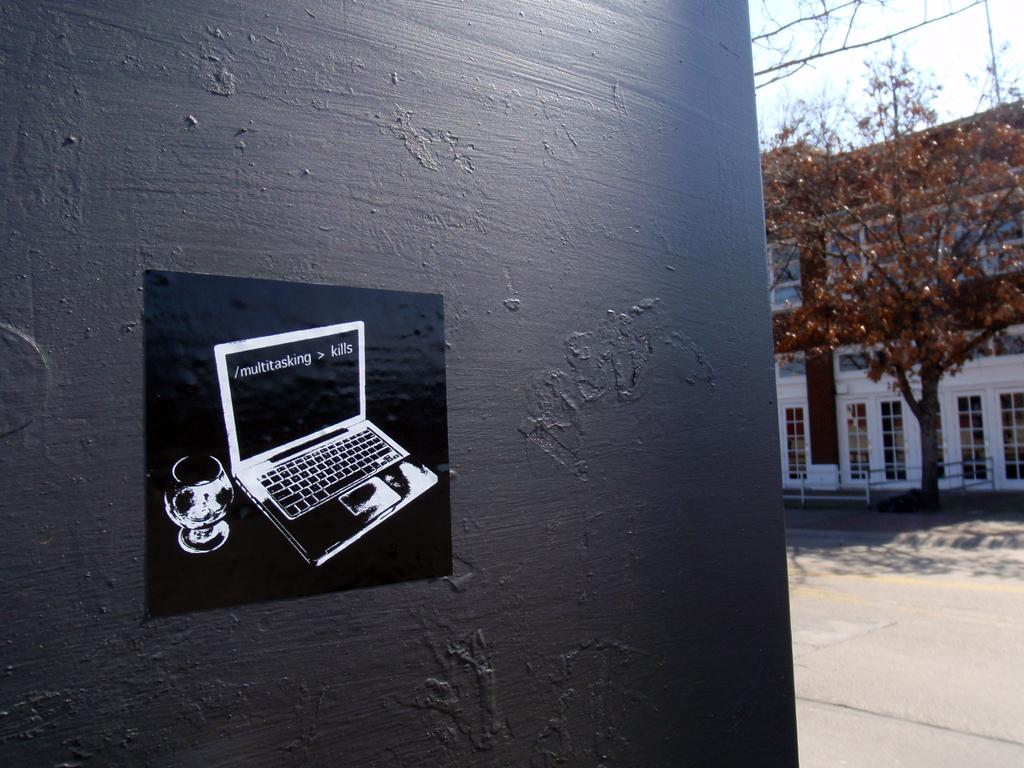<image>
Present a compact description of the photo's key features. a laptop is painted on a wall and says multitasking > kills 